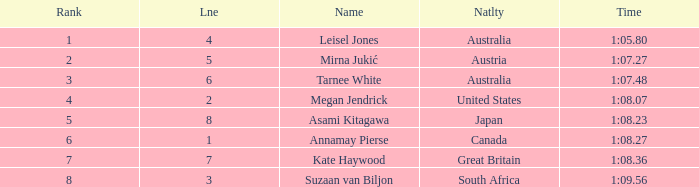For the swimmer ranked 5 or higher in lane 4 or more, what is their nationality? Great Britain. 